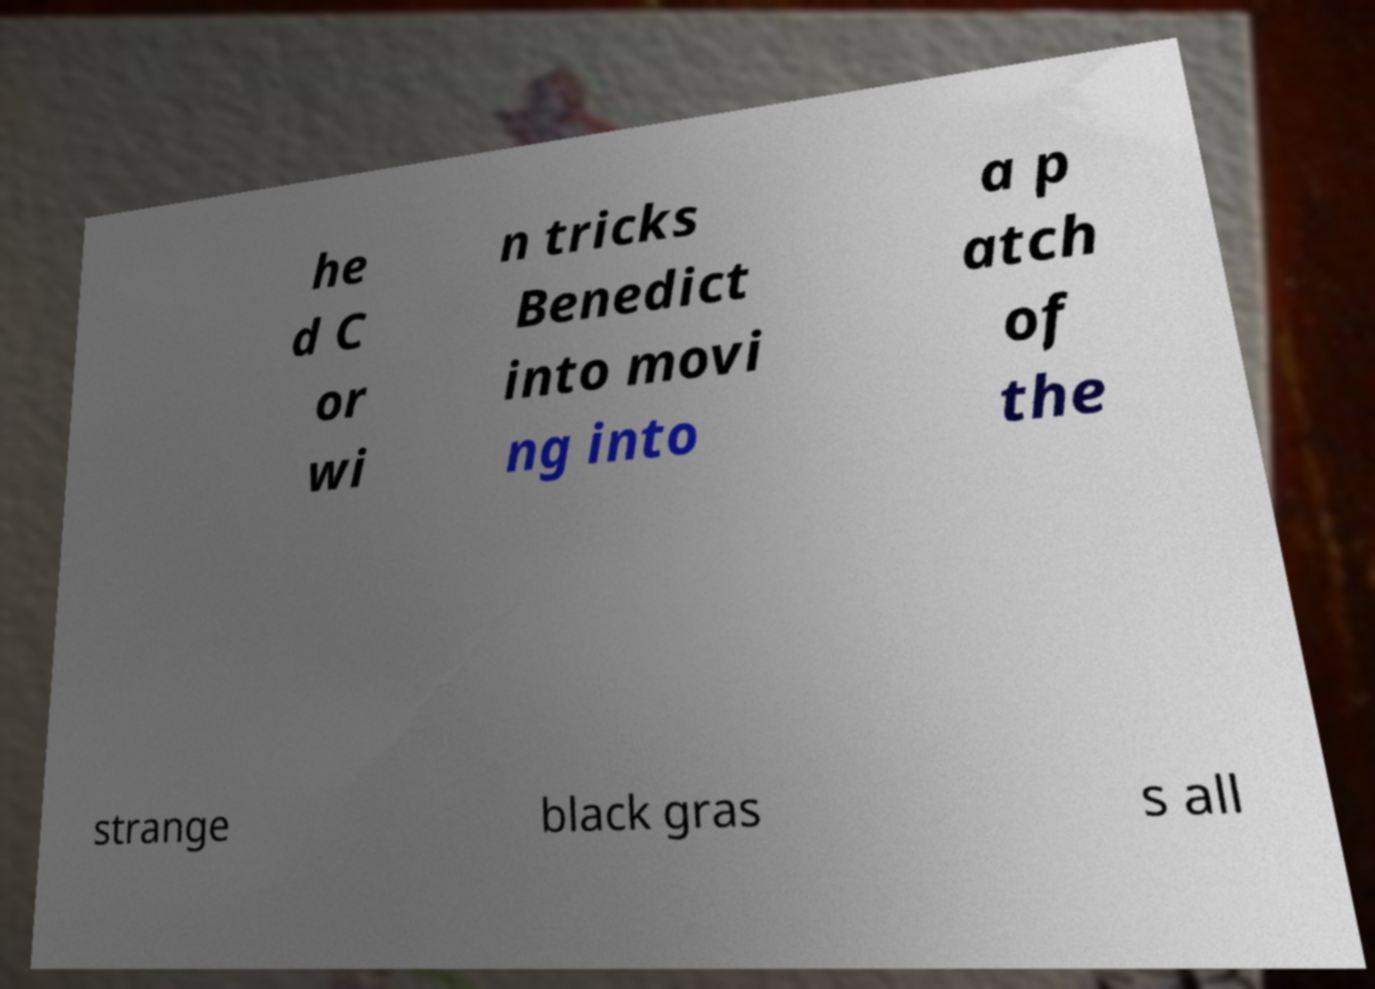Could you extract and type out the text from this image? he d C or wi n tricks Benedict into movi ng into a p atch of the strange black gras s all 